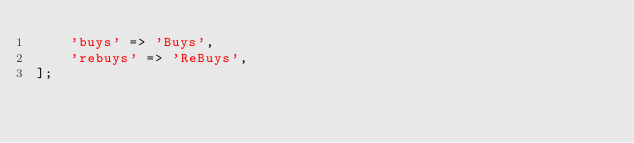<code> <loc_0><loc_0><loc_500><loc_500><_PHP_>    'buys' => 'Buys',
    'rebuys' => 'ReBuys',
];
</code> 